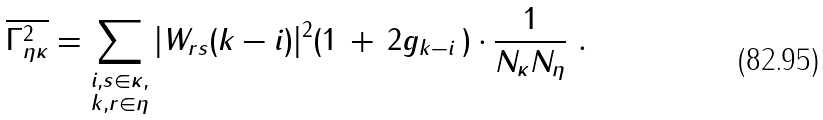Convert formula to latex. <formula><loc_0><loc_0><loc_500><loc_500>\overline { \Gamma _ { \eta \kappa } ^ { 2 } } = \sum _ { \substack { { i } , s \in \kappa , \\ { k } , r \in \eta } } | W _ { r s } ( { k } - { i } ) | ^ { 2 } ( 1 \, + \, 2 g _ { { k } - { i } } \, ) \cdot \frac { 1 } { N _ { \kappa } N _ { \eta } } \ .</formula> 